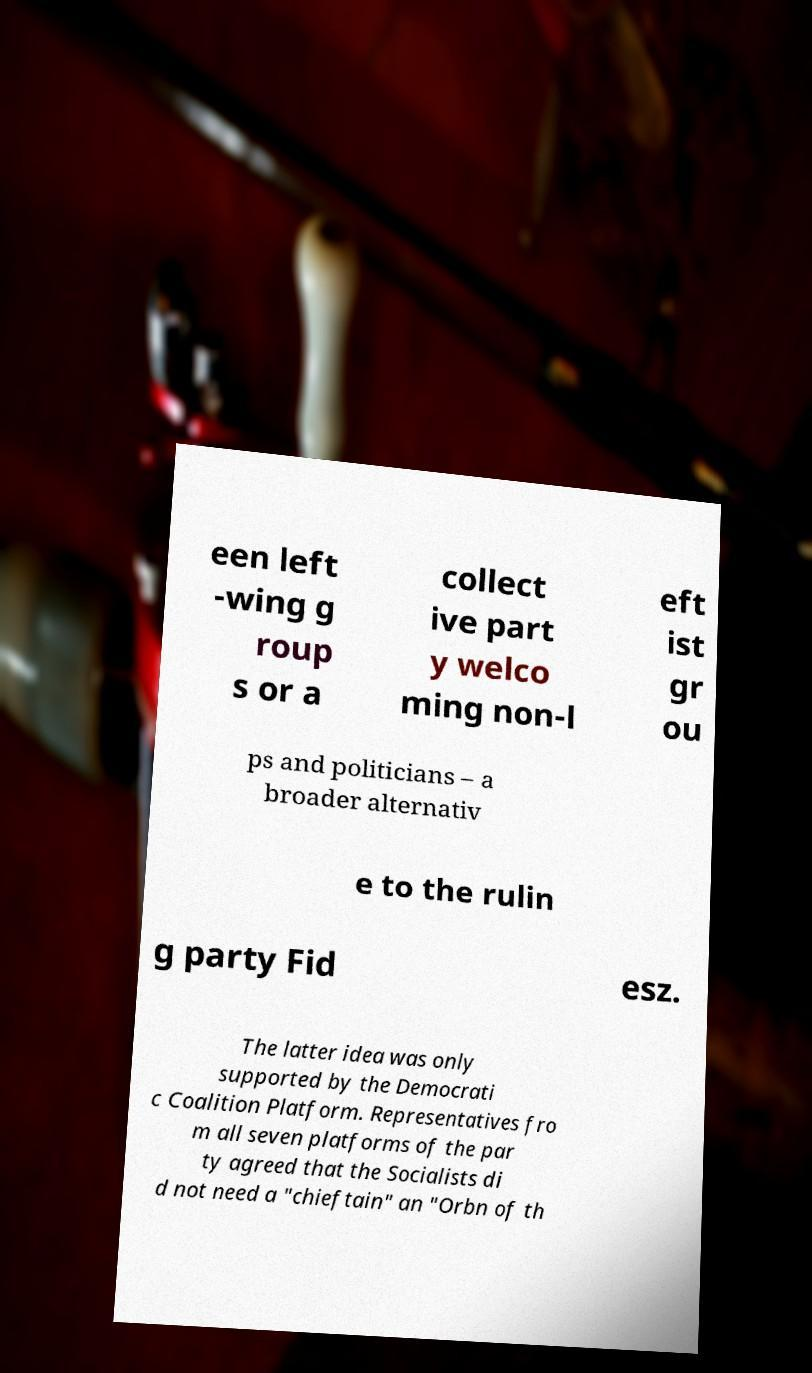Can you read and provide the text displayed in the image?This photo seems to have some interesting text. Can you extract and type it out for me? een left -wing g roup s or a collect ive part y welco ming non-l eft ist gr ou ps and politicians – a broader alternativ e to the rulin g party Fid esz. The latter idea was only supported by the Democrati c Coalition Platform. Representatives fro m all seven platforms of the par ty agreed that the Socialists di d not need a "chieftain" an "Orbn of th 